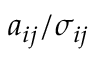<formula> <loc_0><loc_0><loc_500><loc_500>a _ { i j } / \sigma _ { i j }</formula> 